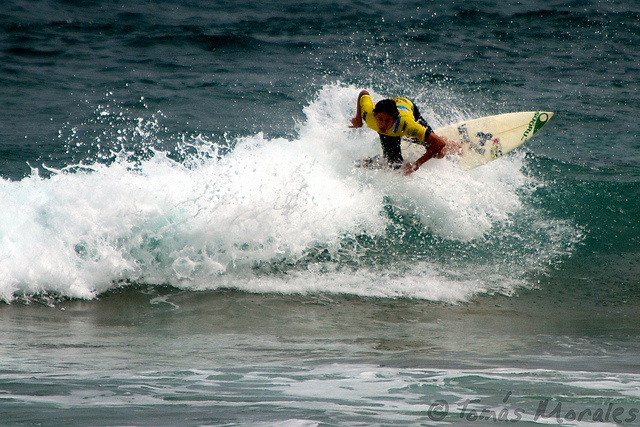Describe the objects in this image and their specific colors. I can see surfboard in black, tan, lightgray, and darkgray tones and people in black, maroon, darkgray, and olive tones in this image. 